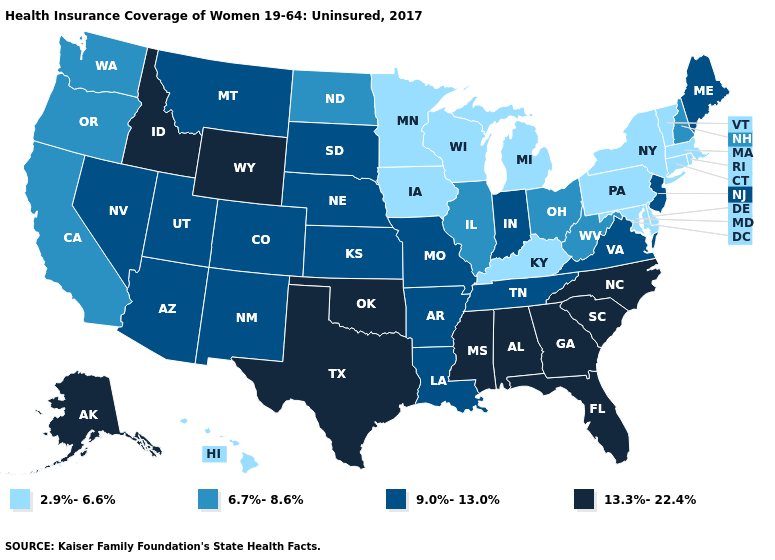Does Michigan have a lower value than Kentucky?
Give a very brief answer. No. What is the highest value in the Northeast ?
Keep it brief. 9.0%-13.0%. Name the states that have a value in the range 9.0%-13.0%?
Concise answer only. Arizona, Arkansas, Colorado, Indiana, Kansas, Louisiana, Maine, Missouri, Montana, Nebraska, Nevada, New Jersey, New Mexico, South Dakota, Tennessee, Utah, Virginia. Name the states that have a value in the range 2.9%-6.6%?
Give a very brief answer. Connecticut, Delaware, Hawaii, Iowa, Kentucky, Maryland, Massachusetts, Michigan, Minnesota, New York, Pennsylvania, Rhode Island, Vermont, Wisconsin. Is the legend a continuous bar?
Give a very brief answer. No. What is the value of Texas?
Write a very short answer. 13.3%-22.4%. What is the highest value in the West ?
Be succinct. 13.3%-22.4%. Is the legend a continuous bar?
Quick response, please. No. What is the highest value in the USA?
Give a very brief answer. 13.3%-22.4%. What is the lowest value in the USA?
Be succinct. 2.9%-6.6%. What is the highest value in the USA?
Keep it brief. 13.3%-22.4%. What is the value of North Dakota?
Concise answer only. 6.7%-8.6%. Does the first symbol in the legend represent the smallest category?
Give a very brief answer. Yes. Which states have the highest value in the USA?
Concise answer only. Alabama, Alaska, Florida, Georgia, Idaho, Mississippi, North Carolina, Oklahoma, South Carolina, Texas, Wyoming. Does Kentucky have the lowest value in the USA?
Quick response, please. Yes. 